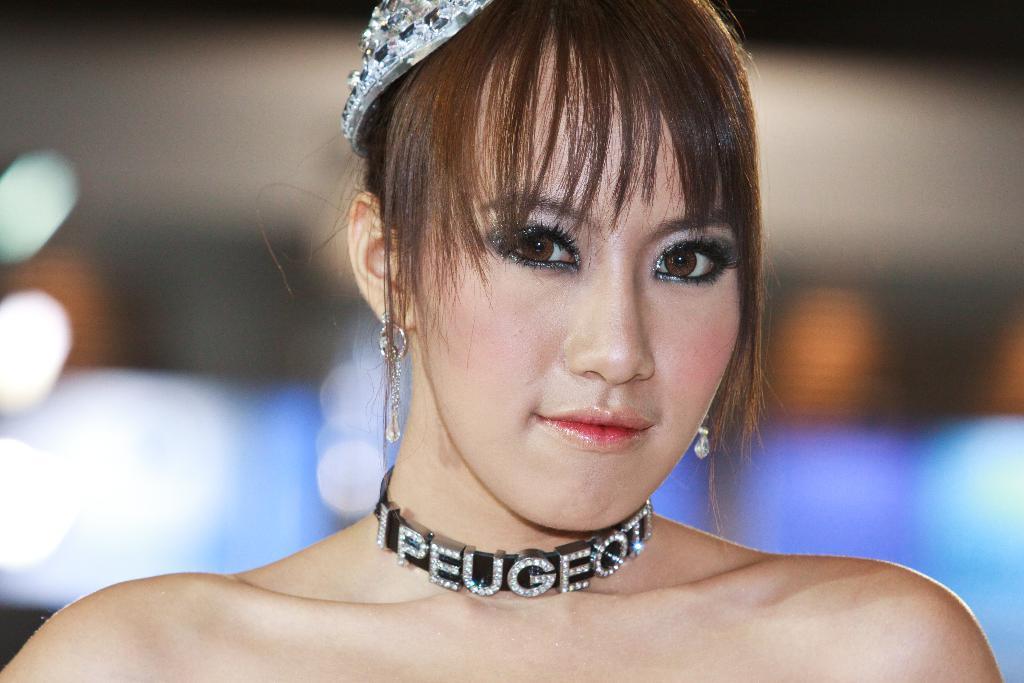Please provide a concise description of this image. In this image we can see a woman wearing the neck piece and also the crown. The background is blurred with the lights. 